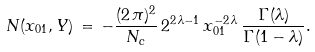<formula> <loc_0><loc_0><loc_500><loc_500>N ( x _ { 0 1 } , Y ) \, = \, - \frac { ( 2 \, \pi ) ^ { 2 } } { N _ { c } } \, 2 ^ { 2 \, \lambda - 1 } \, x _ { 0 1 } ^ { - 2 \, \lambda } \, \frac { \Gamma ( \lambda ) } { \Gamma ( 1 - \lambda ) } .</formula> 